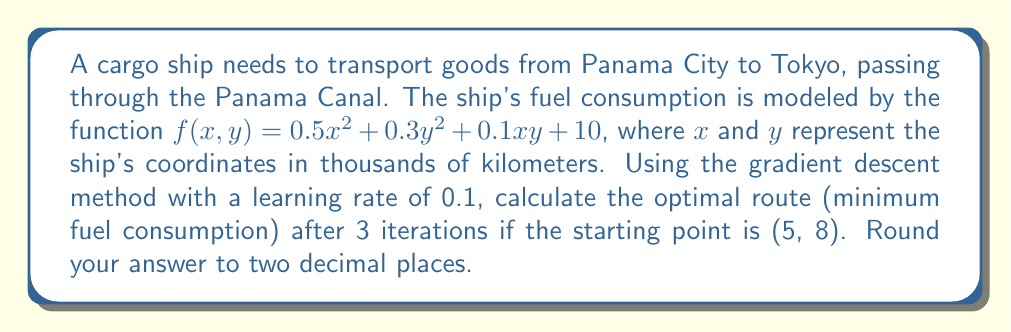Help me with this question. To solve this problem using the gradient descent method, we follow these steps:

1. Define the objective function:
   $f(x,y) = 0.5x^2 + 0.3y^2 + 0.1xy + 10$

2. Calculate the gradient of the function:
   $\nabla f(x,y) = \begin{bmatrix}
   \frac{\partial f}{\partial x} \\
   \frac{\partial f}{\partial y}
   \end{bmatrix} = \begin{bmatrix}
   x + 0.1y \\
   0.6y + 0.1x
   \end{bmatrix}$

3. Initialize the starting point:
   $(x_0, y_0) = (5, 8)$

4. Set the learning rate:
   $\alpha = 0.1$

5. Perform 3 iterations of gradient descent:

   Iteration 1:
   $\nabla f(5, 8) = \begin{bmatrix}
   5 + 0.1(8) \\
   0.6(8) + 0.1(5)
   \end{bmatrix} = \begin{bmatrix}
   5.8 \\
   5.3
   \end{bmatrix}$
   
   $(x_1, y_1) = (5, 8) - 0.1\begin{bmatrix}
   5.8 \\
   5.3
   \end{bmatrix} = (4.42, 7.47)$

   Iteration 2:
   $\nabla f(4.42, 7.47) = \begin{bmatrix}
   4.42 + 0.1(7.47) \\
   0.6(7.47) + 0.1(4.42)
   \end{bmatrix} = \begin{bmatrix}
   5.167 \\
   4.926
   \end{bmatrix}$
   
   $(x_2, y_2) = (4.42, 7.47) - 0.1\begin{bmatrix}
   5.167 \\
   4.926
   \end{bmatrix} = (3.90, 6.98)$

   Iteration 3:
   $\nabla f(3.90, 6.98) = \begin{bmatrix}
   3.90 + 0.1(6.98) \\
   0.6(6.98) + 0.1(3.90)
   \end{bmatrix} = \begin{bmatrix}
   4.598 \\
   4.578
   \end{bmatrix}$
   
   $(x_3, y_3) = (3.90, 6.98) - 0.1\begin{bmatrix}
   4.598 \\
   4.578
   \end{bmatrix} = (3.44, 6.52)$

6. Round the final result to two decimal places:
   $(x_3, y_3) = (3.44, 6.52)$
Answer: (3.44, 6.52) 